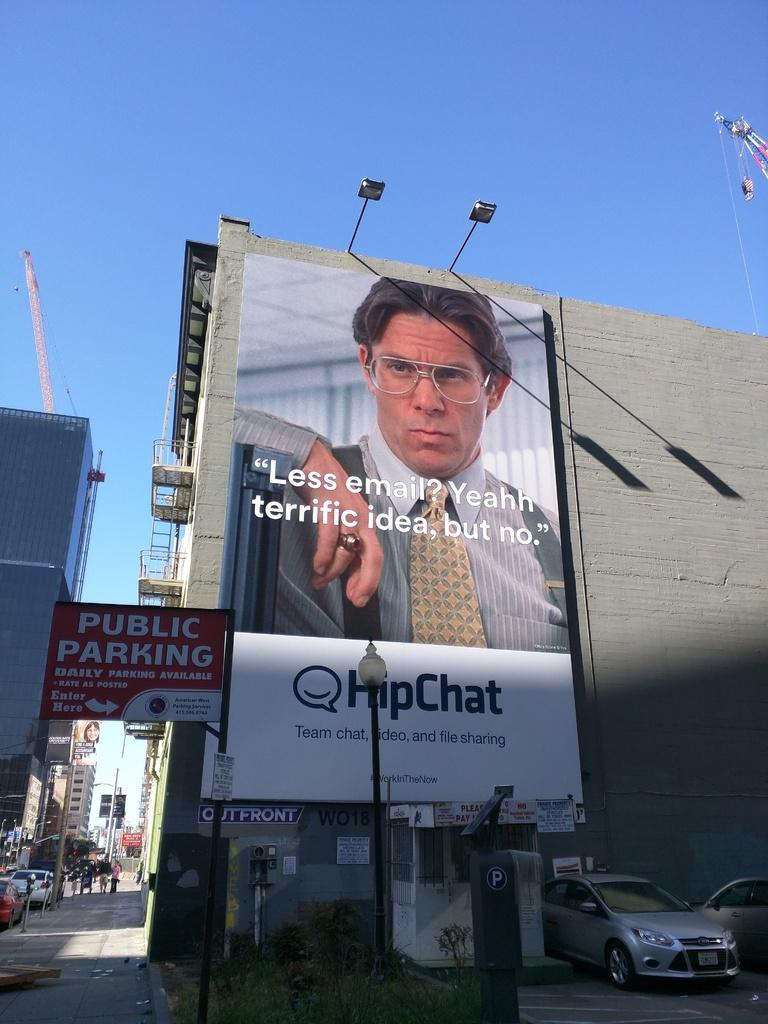<image>
Render a clear and concise summary of the photo. A billboard on the side of a building reading HipChat. 